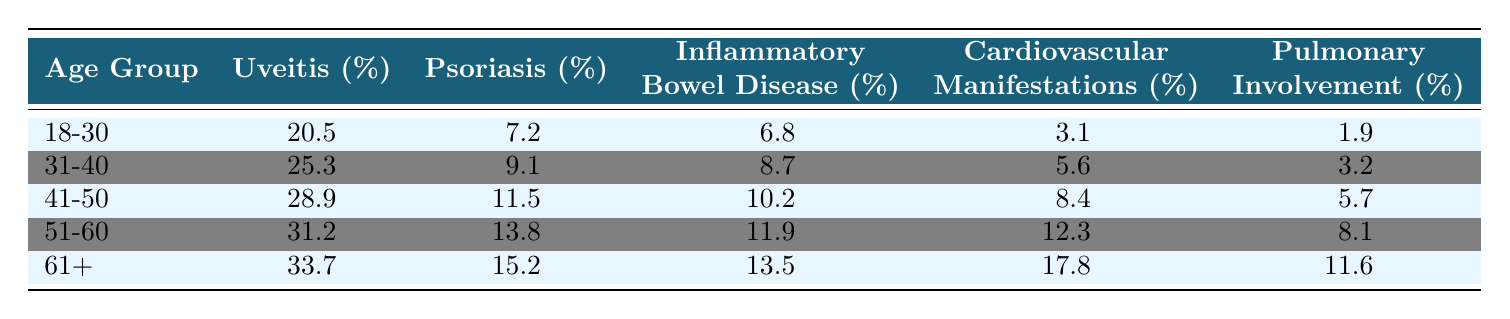What percentage of patients aged 18-30 experience uveitis? The table shows that 20.5% of patients in the 18-30 age group experience uveitis.
Answer: 20.5% Which age group has the highest percentage of cardiovascular manifestations? The table indicates that the 61+ age group has the highest percentage of cardiovascular manifestations at 17.8%.
Answer: 61+ What is the average percentage of psoriasis across all age groups? Summing the percentages of psoriasis: (7.2 + 9.1 + 11.5 + 13.8 + 15.2) = 56.8. Dividing by 5 gives an average of 56.8 / 5 = 11.36%.
Answer: 11.36% Is the percentage of pulmonary involvement higher in the 41-50 age group than in the 31-40 age group? The table shows that pulmonary involvement is 5.7% in the 41-50 age group and 3.2% in the 31-40 age group, indicating it is higher in the 41-50 age group.
Answer: Yes By how much does uveitis percentage increase from the 18-30 age group to the 61+ age group? The percentage of uveitis in the 18-30 age group is 20.5% and in the 61+ age group is 33.7%. Subtracting these gives 33.7 - 20.5 = 13.2%.
Answer: 13.2% Which extra-articular manifestation shows the largest increase in percentage from age group 51-60 to 61+? Comparing the two age groups: Uveitis increases from 31.2% to 33.7% (2.5% increase), Psoriasis from 13.8% to 15.2% (1.4% increase), Inflammatory Bowel Disease from 11.9% to 13.5% (1.6% increase), Cardiovascular from 12.3% to 17.8% (5.5% increase), and Pulmonary from 8.1% to 11.6% (3.5% increase). The largest increase is in Cardiovascular manifestations by 5.5%.
Answer: Cardiovascular manifestations What percentage of patients aged 41-50 experience inflammatory bowel disease? The table lists that 10.2% of patients in the 41-50 age group experience inflammatory bowel disease.
Answer: 10.2% What is the difference in the percentage of pulmonary involvement between the youngest (18-30) and oldest (61+) age groups? The percentage of pulmonary involvement in the 18-30 age group is 1.9% and in the 61+ age group is 11.6%. The difference is 11.6 - 1.9 = 9.7%.
Answer: 9.7% Is it true that Psoriasis is more prevalent in age groups older than 40? The percentages in age groups older than 40 are: 41-50 (11.5%), 51-60 (13.8%), and 61+ (15.2%). Since all these percentages are greater than 9.1% in the 31-40 age group, it is true that psoriasis is more prevalent in age groups older than 40.
Answer: Yes What is the total percentage of all extra-articular manifestations for the 51-60 age group? Adding the percentages for the 51-60 age group: Uveitis (31.2) + Psoriasis (13.8) + Inflammatory Bowel Disease (11.9) + Cardiovascular (12.3) + Pulmonary (8.1) = 77.3%.
Answer: 77.3% 